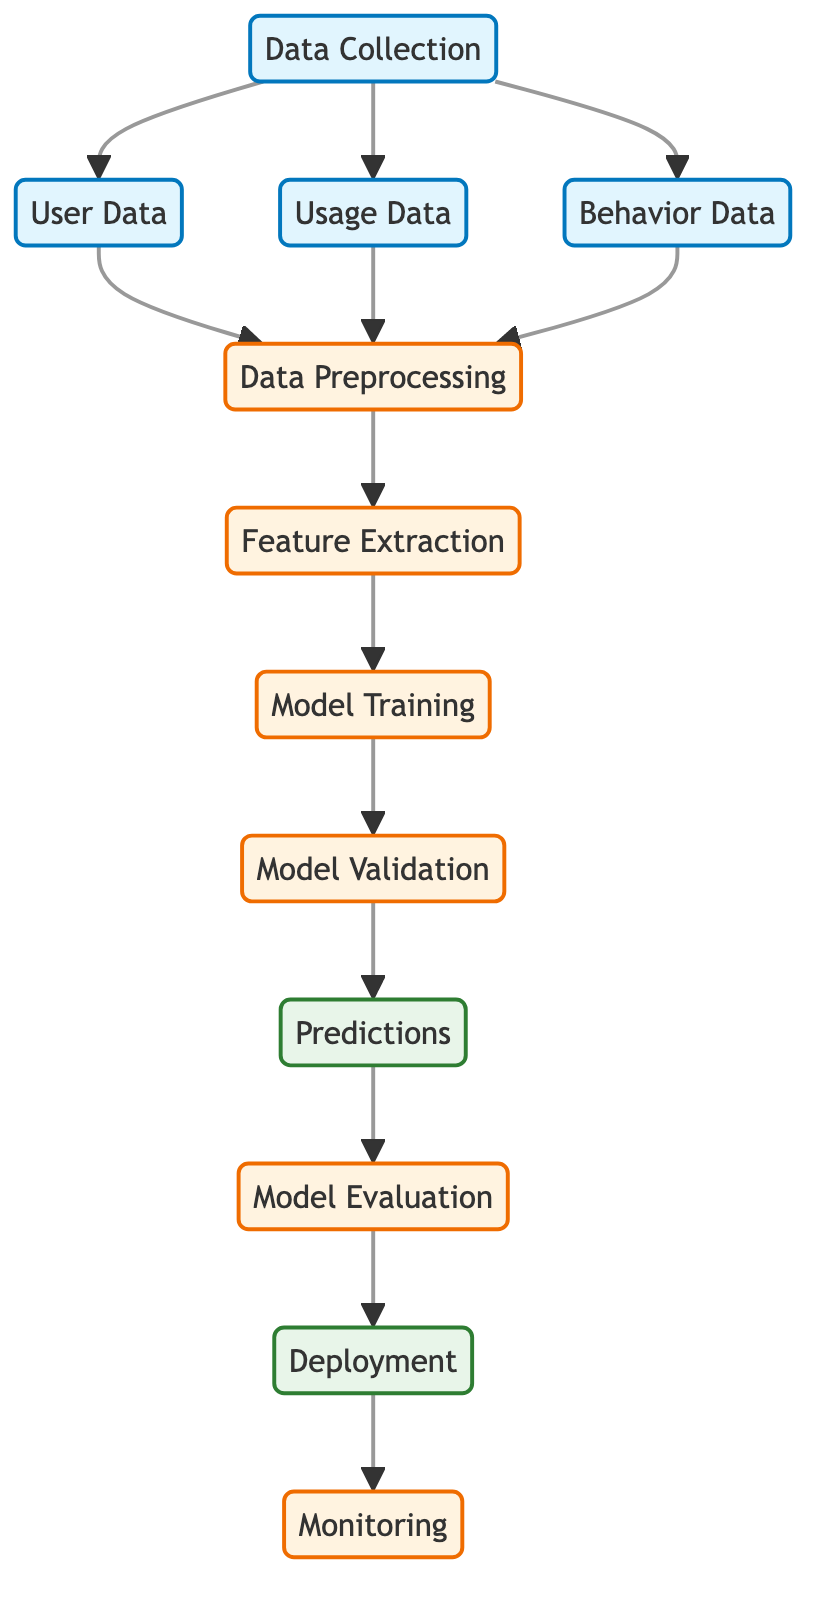What are the three types of data collected? The diagram indicates three types of data that are collected: User Data, Usage Data, and Behavior Data. These are directly listed as data nodes under the Data Collection node.
Answer: User Data, Usage Data, Behavior Data How many process nodes are in the diagram? The diagram contains five process nodes: Data Preprocessing, Feature Extraction, Model Training, Model Validation, and Model Evaluation. This can be counted directly from the diagram.
Answer: Five What node follows the Data Preprocessing node? The arrow from the Data Preprocessing node leads to the Feature Extraction node. This indicates that Feature Extraction is the next step after Data Preprocessing in the flow.
Answer: Feature Extraction What is the final output of the model? The last node in the flow of the diagram is Monitoring, which indicates it is the final output after Deployment. This means after deploying the model, Monitoring is the core output activity.
Answer: Monitoring Which node connects to the validation stage? The Model Training node connects to the Model Validation node, as indicated by the directed arrow between the two nodes in the diagram.
Answer: Model Training What operation comes after Model Validation? The Predictions node follows the Model Validation node, indicating that the next step after validating the model is to make predictions based on the validated model.
Answer: Predictions What is the primary purpose of the Deployment node? The purpose of the Deployment node is to implement the trained model into a real-world environment where it can be used for making predictions and further monitoring. This can be inferred from the context of the flowchart.
Answer: Implementing the model Which node represents the initial step in the flow? The Data Collection node is the initial step in the diagram. It is the first node from which all other data and processing branches out in the workflow.
Answer: Data Collection How many arrows point out from the Data Collection node? There are three arrows pointing out from the Data Collection node leading to User Data, Usage Data, and Behavior Data, indicating the three types of data that are collected.
Answer: Three 